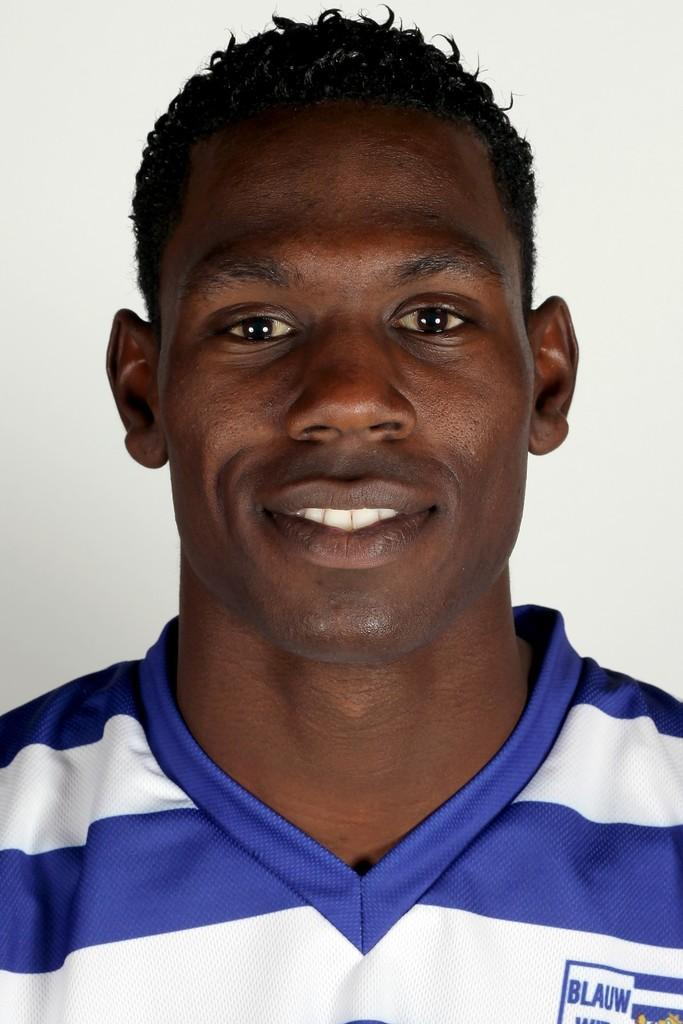Provide a one-sentence caption for the provided image. Headshot of man in striped blue and white shirt that reads "Blauw". 